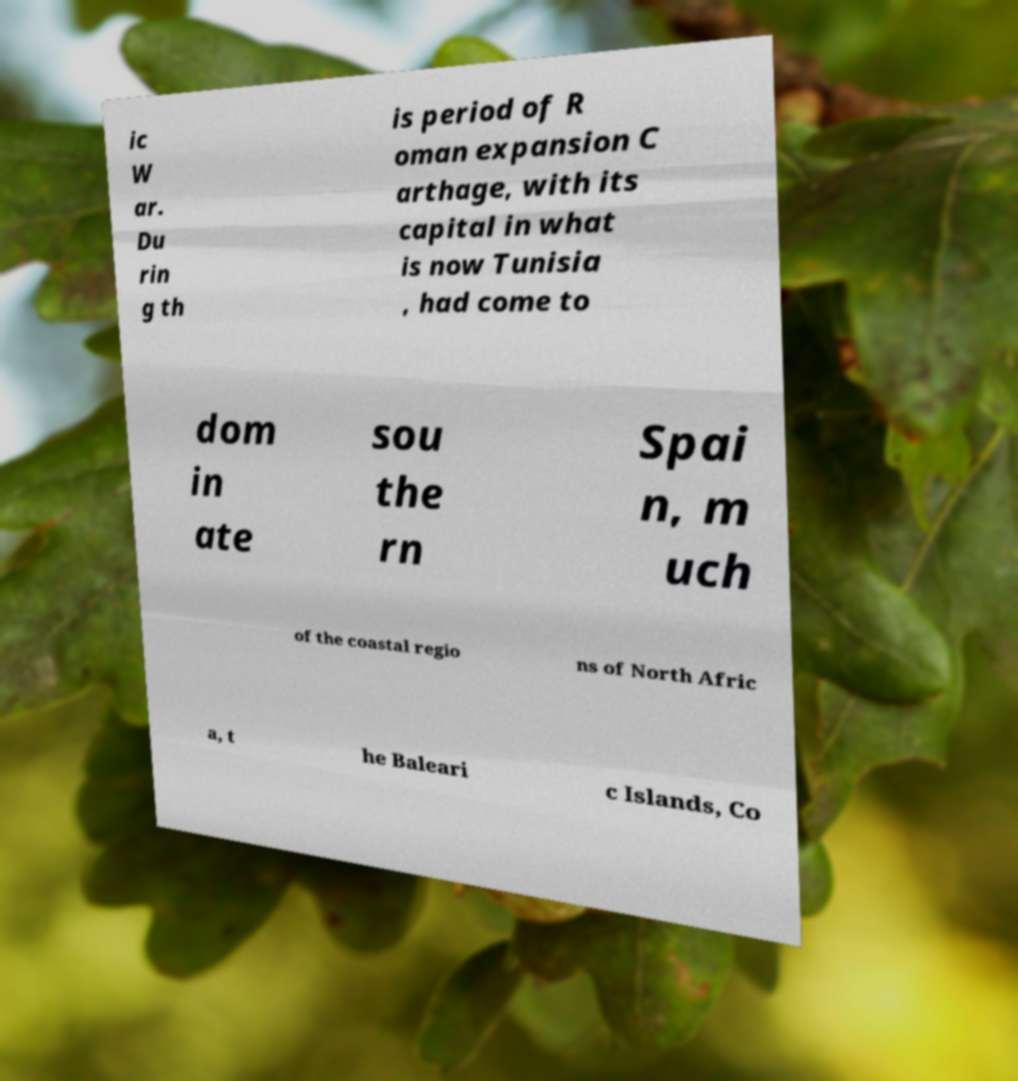What messages or text are displayed in this image? I need them in a readable, typed format. ic W ar. Du rin g th is period of R oman expansion C arthage, with its capital in what is now Tunisia , had come to dom in ate sou the rn Spai n, m uch of the coastal regio ns of North Afric a, t he Baleari c Islands, Co 